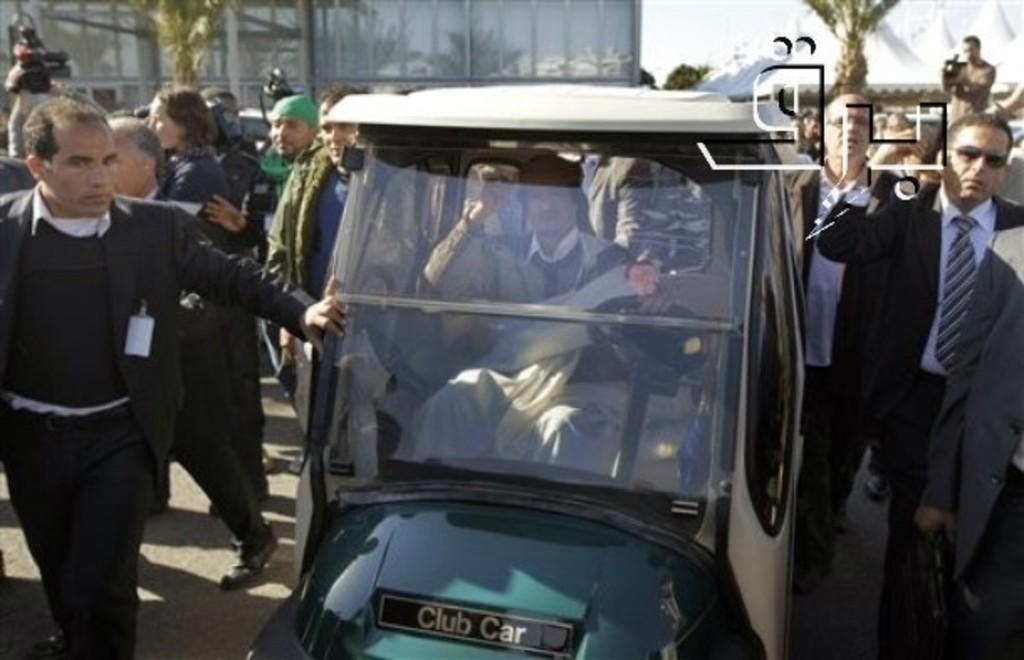What can be seen in the distance in the image? There is a building and trees in the distance in the image. What are the people in the image doing? There are persons standing in the image, and one person is sitting inside a vehicle. What is the person sitting inside the vehicle holding? The person sitting inside the vehicle is holding a camera. What type of mint is growing near the building in the image? There is no mint visible in the image; it only features a building and trees in the distance. What kind of toys are the persons playing with in the image? There are no toys present in the image; the persons are standing or sitting inside a vehicle. 